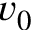<formula> <loc_0><loc_0><loc_500><loc_500>v _ { 0 }</formula> 